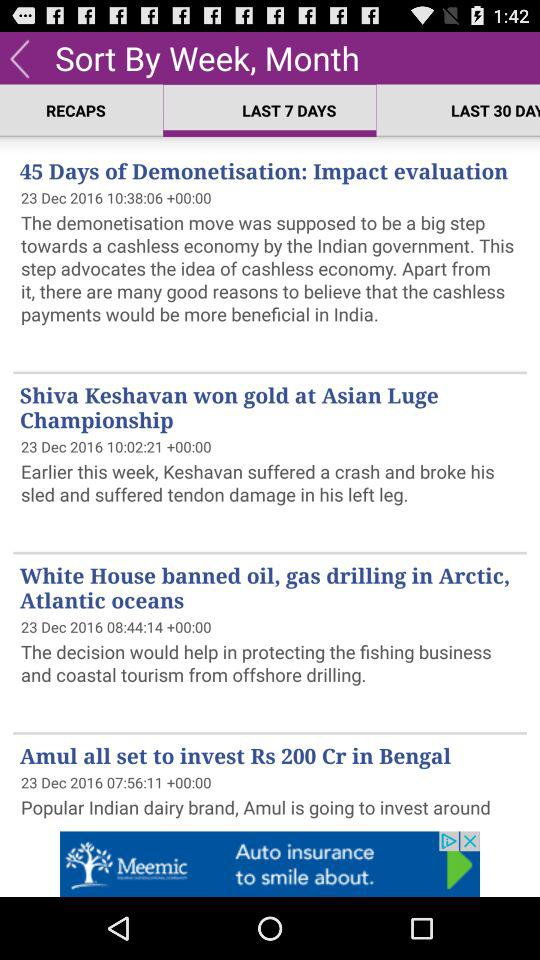How many articles are in "LAST 30 DAYS"?
When the provided information is insufficient, respond with <no answer>. <no answer> 